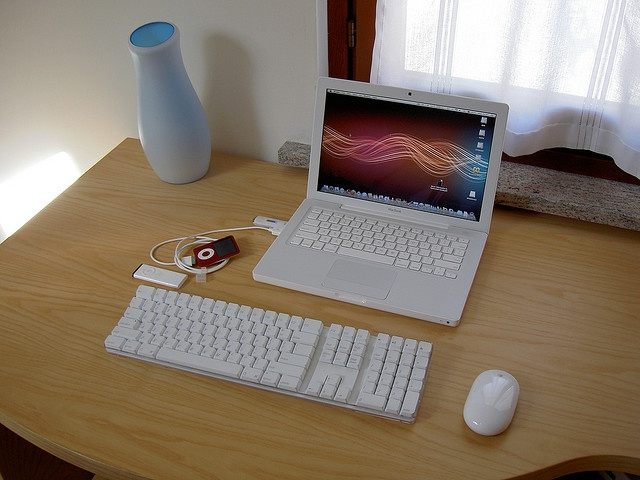Describe the objects in this image and their specific colors. I can see laptop in gray, darkgray, black, and maroon tones, keyboard in gray and darkgray tones, vase in gray tones, and mouse in gray and darkgray tones in this image. 